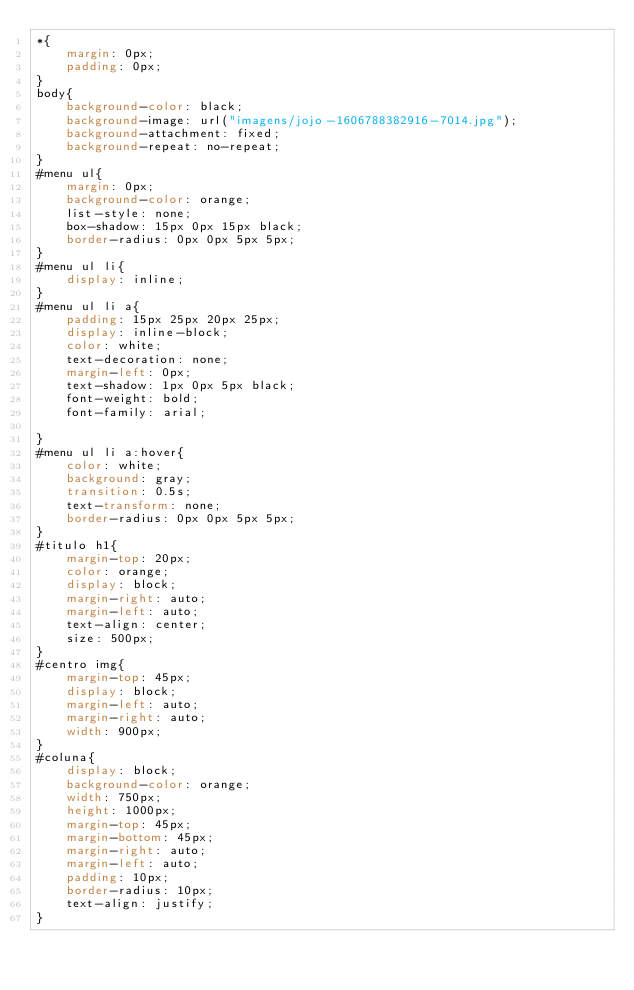<code> <loc_0><loc_0><loc_500><loc_500><_CSS_>*{
	margin: 0px;
	padding: 0px;
}
body{
	background-color: black;
	background-image: url("imagens/jojo-1606788382916-7014.jpg");
	background-attachment: fixed;
	background-repeat: no-repeat;
}
#menu ul{
	margin: 0px;
	background-color: orange;
	list-style: none;
	box-shadow: 15px 0px 15px black;
	border-radius: 0px 0px 5px 5px;
}
#menu ul li{
	display: inline;
}
#menu ul li a{
	padding: 15px 25px 20px 25px;
	display: inline-block;
	color: white;
	text-decoration: none;
	margin-left: 0px;
	text-shadow: 1px 0px 5px black;
	font-weight: bold;
	font-family: arial;

}
#menu ul li a:hover{
	color: white;
	background: gray;
	transition: 0.5s;
	text-transform: none;
	border-radius: 0px 0px 5px 5px;
}
#titulo h1{
	margin-top: 20px;
	color: orange;
	display: block;
	margin-right: auto;
	margin-left: auto;
	text-align: center;
	size: 500px;
}
#centro img{
	margin-top: 45px;
	display: block;
	margin-left: auto;
	margin-right: auto;
	width: 900px;
}
#coluna{
	display: block;
	background-color: orange;
	width: 750px;
	height: 1000px;
	margin-top: 45px;
	margin-bottom: 45px;
	margin-right: auto;
	margin-left: auto;
	padding: 10px;
	border-radius: 10px;
	text-align: justify;
}</code> 